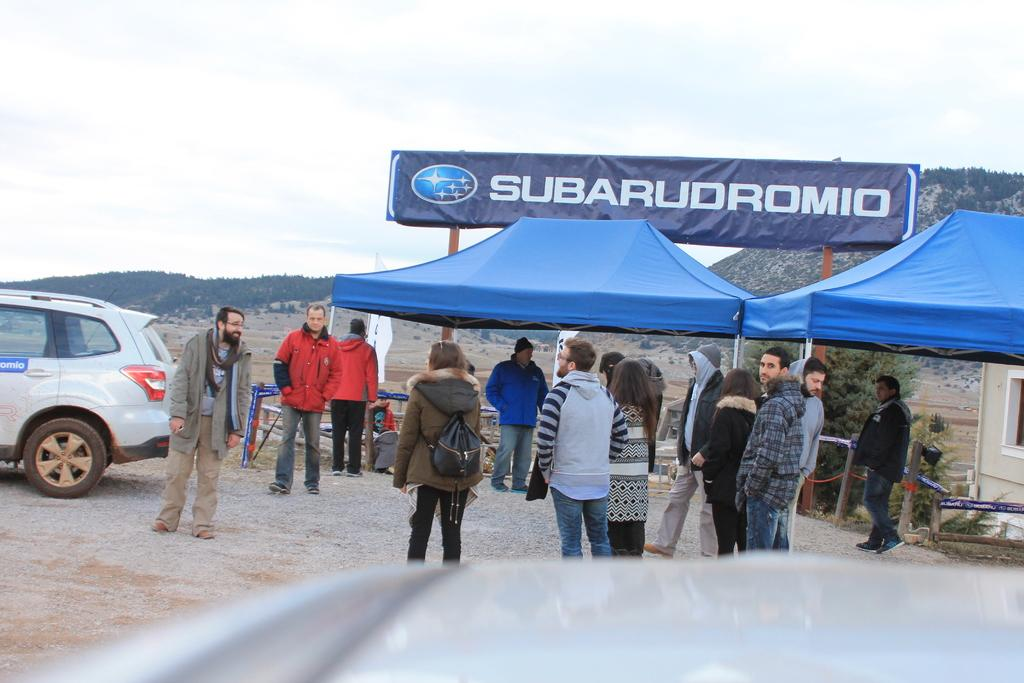How many people can be seen in the image? There are many people in the image. What structures are located on the right side of the image? There are tents on the right side of the image. What is on the left side of the image? There is a vehicle on the left side of the image. What is near the tents? There is a banner near the tents. What can be seen in the background of the image? There is a hill and the sky visible in the background of the image. How many dogs are lying on the bed in the image? There are no dogs or beds present in the image. What causes the people in the image to laugh? There is no indication of laughter in the image, so it cannot be determined from the image. 